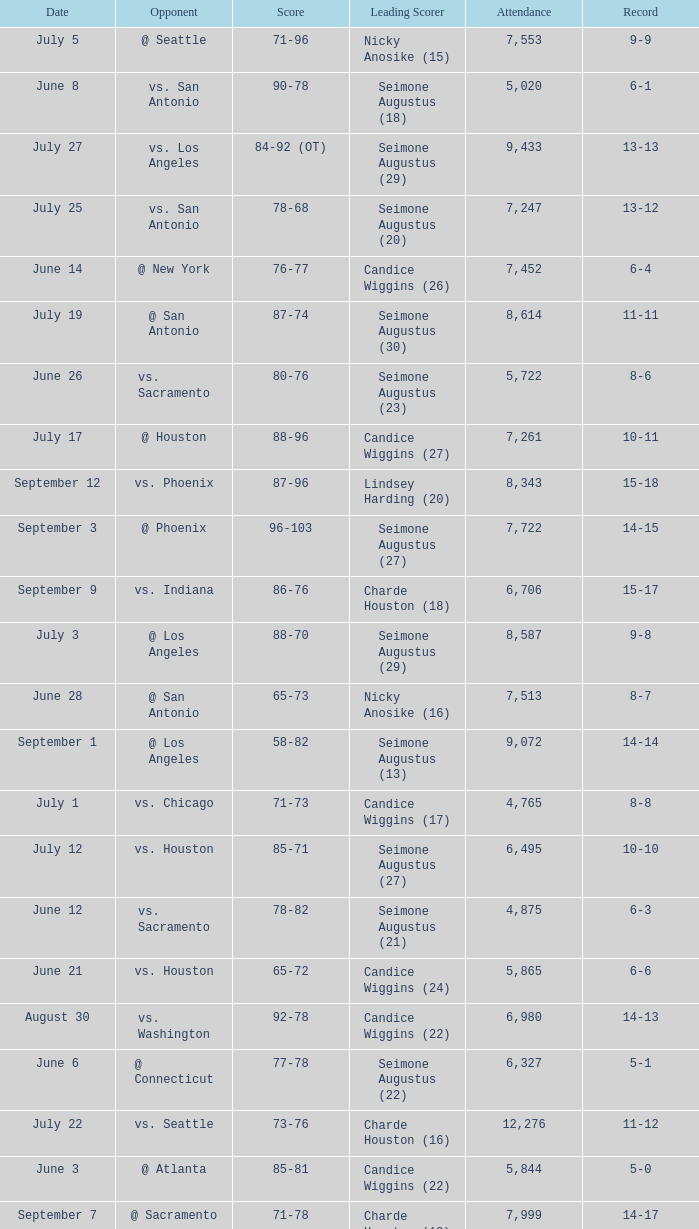Which Score has an Opponent of @ houston, and a Record of 2-0? 98-92 (OT). Would you mind parsing the complete table? {'header': ['Date', 'Opponent', 'Score', 'Leading Scorer', 'Attendance', 'Record'], 'rows': [['July 5', '@ Seattle', '71-96', 'Nicky Anosike (15)', '7,553', '9-9'], ['June 8', 'vs. San Antonio', '90-78', 'Seimone Augustus (18)', '5,020', '6-1'], ['July 27', 'vs. Los Angeles', '84-92 (OT)', 'Seimone Augustus (29)', '9,433', '13-13'], ['July 25', 'vs. San Antonio', '78-68', 'Seimone Augustus (20)', '7,247', '13-12'], ['June 14', '@ New York', '76-77', 'Candice Wiggins (26)', '7,452', '6-4'], ['July 19', '@ San Antonio', '87-74', 'Seimone Augustus (30)', '8,614', '11-11'], ['June 26', 'vs. Sacramento', '80-76', 'Seimone Augustus (23)', '5,722', '8-6'], ['July 17', '@ Houston', '88-96', 'Candice Wiggins (27)', '7,261', '10-11'], ['September 12', 'vs. Phoenix', '87-96', 'Lindsey Harding (20)', '8,343', '15-18'], ['September 3', '@ Phoenix', '96-103', 'Seimone Augustus (27)', '7,722', '14-15'], ['September 9', 'vs. Indiana', '86-76', 'Charde Houston (18)', '6,706', '15-17'], ['July 3', '@ Los Angeles', '88-70', 'Seimone Augustus (29)', '8,587', '9-8'], ['June 28', '@ San Antonio', '65-73', 'Nicky Anosike (16)', '7,513', '8-7'], ['September 1', '@ Los Angeles', '58-82', 'Seimone Augustus (13)', '9,072', '14-14'], ['July 1', 'vs. Chicago', '71-73', 'Candice Wiggins (17)', '4,765', '8-8'], ['July 12', 'vs. Houston', '85-71', 'Seimone Augustus (27)', '6,495', '10-10'], ['June 12', 'vs. Sacramento', '78-82', 'Seimone Augustus (21)', '4,875', '6-3'], ['June 21', 'vs. Houston', '65-72', 'Candice Wiggins (24)', '5,865', '6-6'], ['August 30', 'vs. Washington', '92-78', 'Candice Wiggins (22)', '6,980', '14-13'], ['June 6', '@ Connecticut', '77-78', 'Seimone Augustus (22)', '6,327', '5-1'], ['July 22', 'vs. Seattle', '73-76', 'Charde Houston (16)', '12,276', '11-12'], ['June 3', '@ Atlanta', '85-81', 'Candice Wiggins (22)', '5,844', '5-0'], ['September 7', '@ Sacramento', '71-78', 'Charde Houston (19)', '7,999', '14-17'], ['May 31', 'vs. Phoenix', '94-83', 'Seimone Augustus (22)', '6,914', '4-0'], ['September 14', '@ Washington', '96-70', 'Charde Houston (18)', '10,438', '16-18'], ['September 6', '@ Seattle', '88-96', 'Seimone Augustus (26)', '9,339', '14-16'], ['June 20', '@ Detroit', '93-98 (OT)', 'Seimone Augustus (26)', '8,916', '6-5'], ['June 24', 'vs. New York', '91-69', 'Seimone Augustus (21)', '6,280', '7-6'], ['May 27', '@ Houston', '98-92 (OT)', 'Seimone Augustus (25)', '7,261', '2-0'], ['May 18', 'vs. Detroit', '84-70', 'Charde Houston (21)', '9,972', '1-0'], ['July 24', '@ Indiana', '84-80 (OT)', 'Seimone Augustus (25)', '6,010', '12-12'], ['June 10', 'vs. Connecticut', '66-75', 'Candice Wiggins (22)', '7,186', '6-2'], ['July 9', 'vs. Atlanta', '67-73', 'Seimone Augustus (17)', '5,893', '9-10'], ['May 29', '@ Chicago', '75-69', 'Seimone Augustus (19)', '3,014', '3-0']]} 